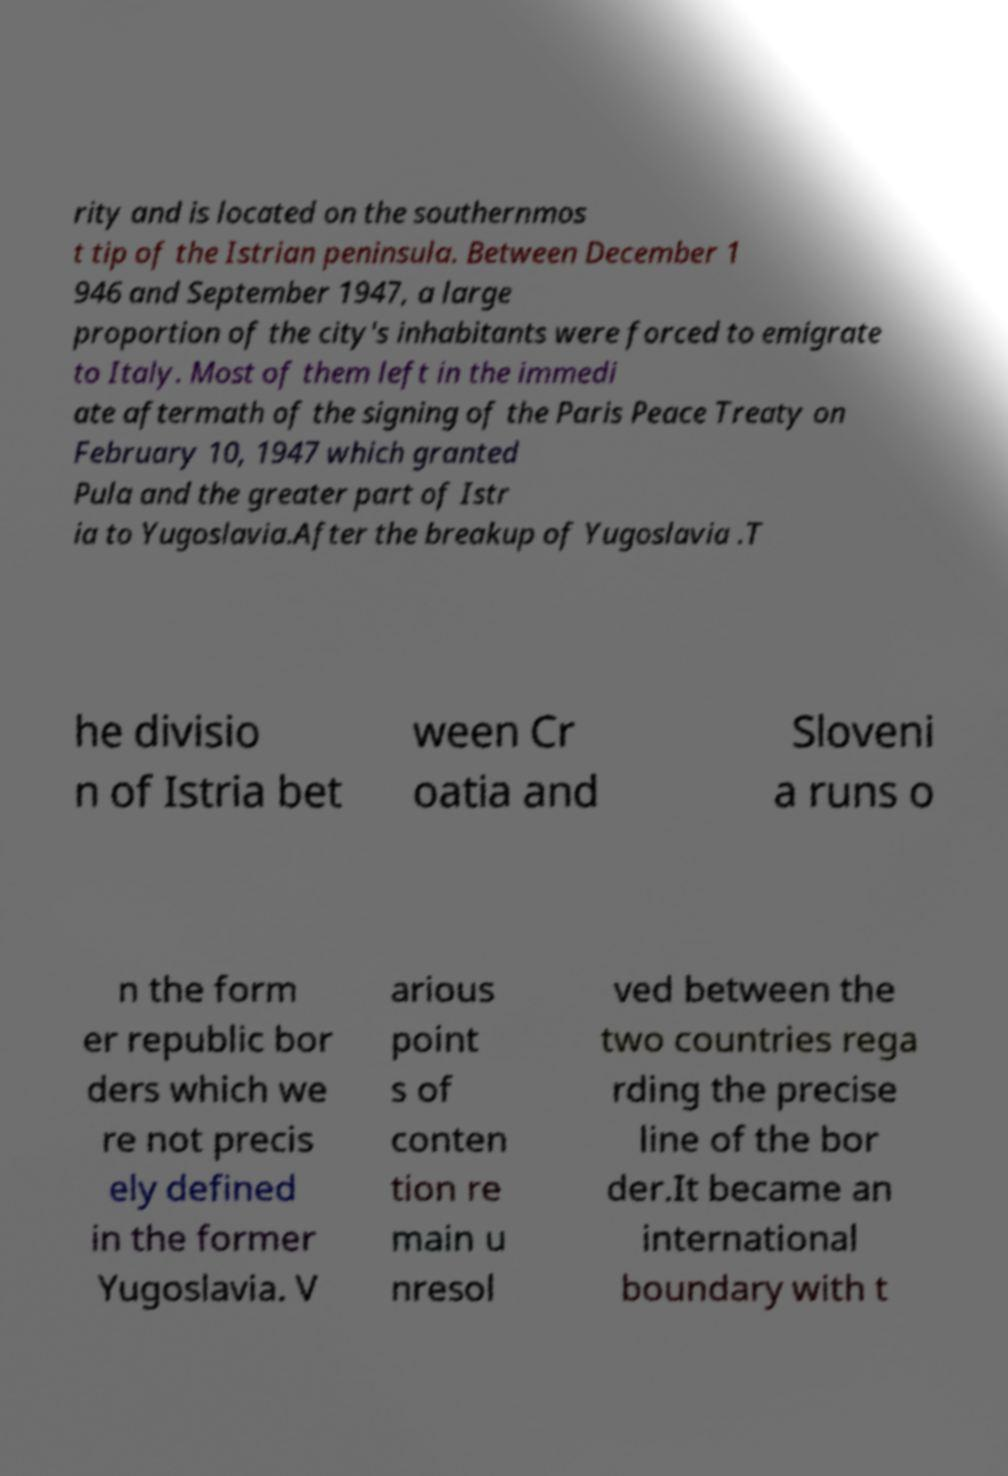Can you read and provide the text displayed in the image?This photo seems to have some interesting text. Can you extract and type it out for me? rity and is located on the southernmos t tip of the Istrian peninsula. Between December 1 946 and September 1947, a large proportion of the city's inhabitants were forced to emigrate to Italy. Most of them left in the immedi ate aftermath of the signing of the Paris Peace Treaty on February 10, 1947 which granted Pula and the greater part of Istr ia to Yugoslavia.After the breakup of Yugoslavia .T he divisio n of Istria bet ween Cr oatia and Sloveni a runs o n the form er republic bor ders which we re not precis ely defined in the former Yugoslavia. V arious point s of conten tion re main u nresol ved between the two countries rega rding the precise line of the bor der.It became an international boundary with t 